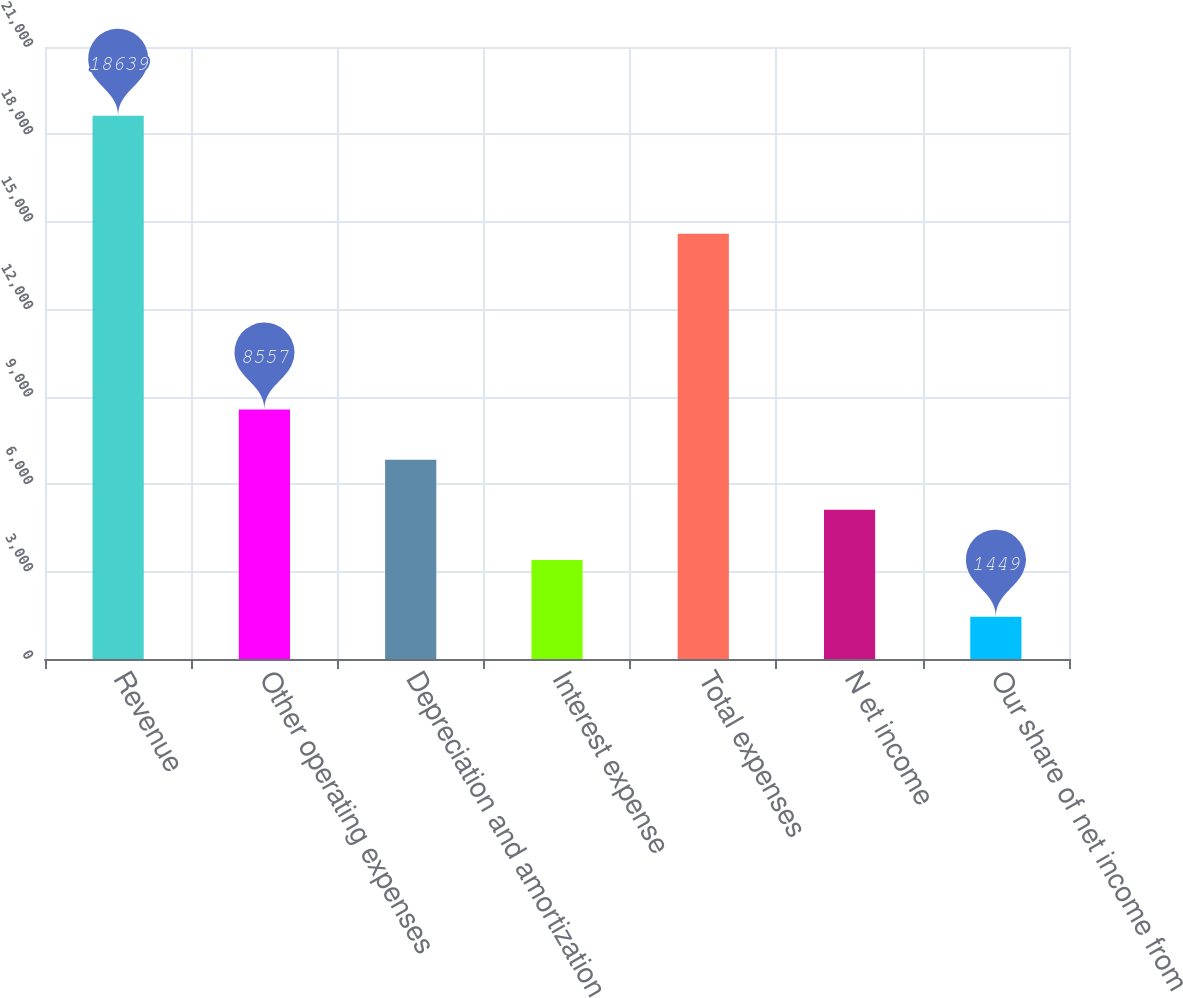<chart> <loc_0><loc_0><loc_500><loc_500><bar_chart><fcel>Revenue<fcel>Other operating expenses<fcel>Depreciation and amortization<fcel>Interest expense<fcel>Total expenses<fcel>N et income<fcel>Our share of net income from<nl><fcel>18639<fcel>8557<fcel>6838<fcel>3400<fcel>14595<fcel>5119<fcel>1449<nl></chart> 